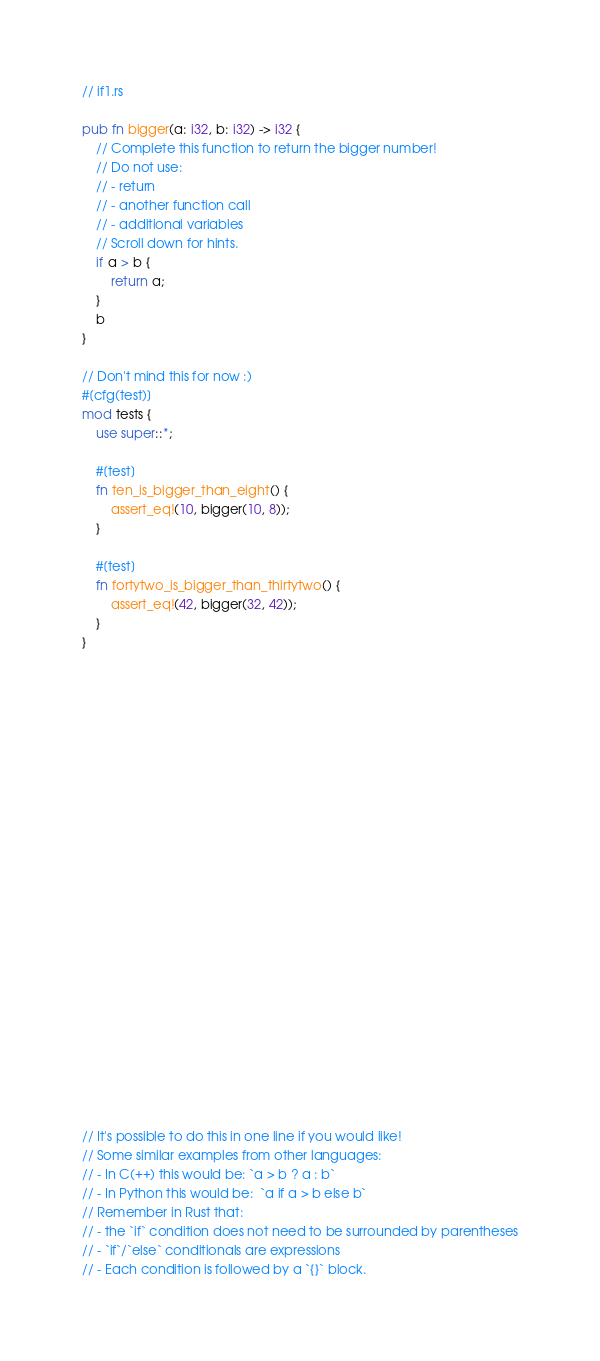<code> <loc_0><loc_0><loc_500><loc_500><_Rust_>// if1.rs

pub fn bigger(a: i32, b: i32) -> i32 {
    // Complete this function to return the bigger number!
    // Do not use:
    // - return
    // - another function call
    // - additional variables
    // Scroll down for hints.
    if a > b {
        return a;
    }
    b
}

// Don't mind this for now :)
#[cfg(test)]
mod tests {
    use super::*;

    #[test]
    fn ten_is_bigger_than_eight() {
        assert_eq!(10, bigger(10, 8));
    }

    #[test]
    fn fortytwo_is_bigger_than_thirtytwo() {
        assert_eq!(42, bigger(32, 42));
    }
}

























// It's possible to do this in one line if you would like!
// Some similar examples from other languages:
// - In C(++) this would be: `a > b ? a : b`
// - In Python this would be:  `a if a > b else b`
// Remember in Rust that:
// - the `if` condition does not need to be surrounded by parentheses
// - `if`/`else` conditionals are expressions
// - Each condition is followed by a `{}` block.
</code> 